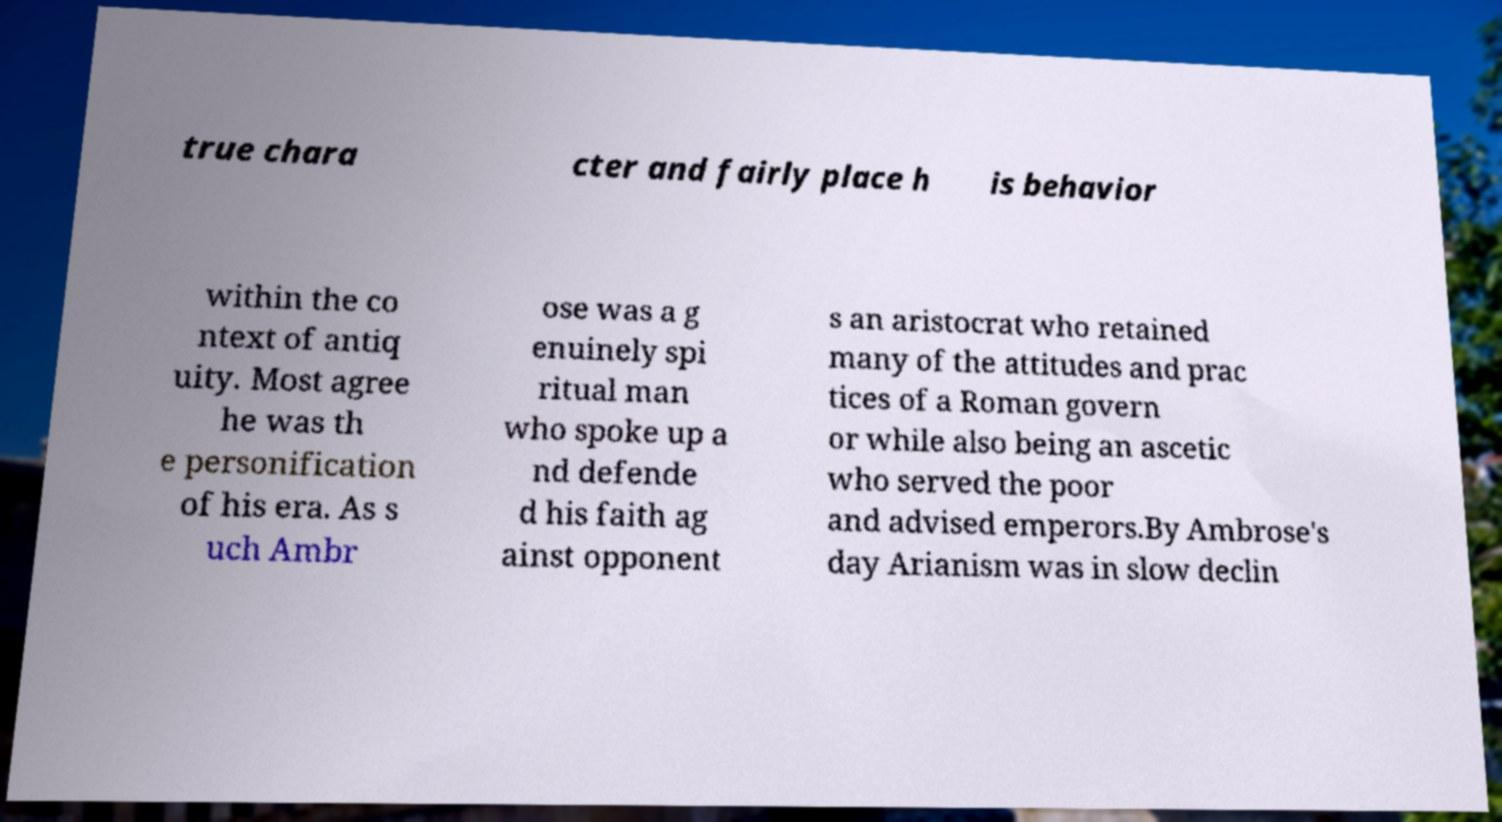Can you accurately transcribe the text from the provided image for me? true chara cter and fairly place h is behavior within the co ntext of antiq uity. Most agree he was th e personification of his era. As s uch Ambr ose was a g enuinely spi ritual man who spoke up a nd defende d his faith ag ainst opponent s an aristocrat who retained many of the attitudes and prac tices of a Roman govern or while also being an ascetic who served the poor and advised emperors.By Ambrose's day Arianism was in slow declin 